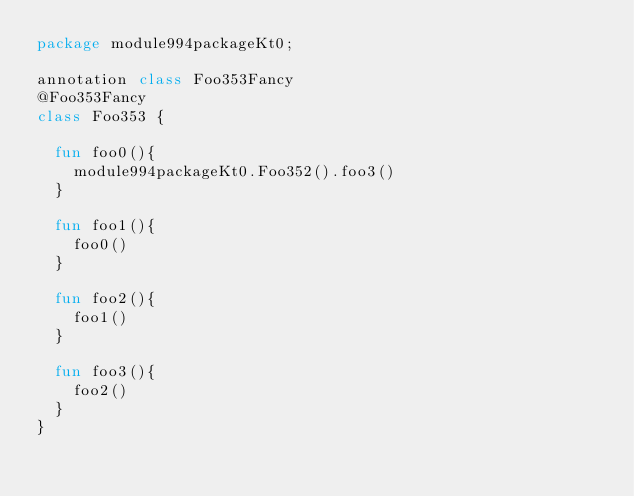<code> <loc_0><loc_0><loc_500><loc_500><_Kotlin_>package module994packageKt0;

annotation class Foo353Fancy
@Foo353Fancy
class Foo353 {

  fun foo0(){
    module994packageKt0.Foo352().foo3()
  }

  fun foo1(){
    foo0()
  }

  fun foo2(){
    foo1()
  }

  fun foo3(){
    foo2()
  }
}</code> 